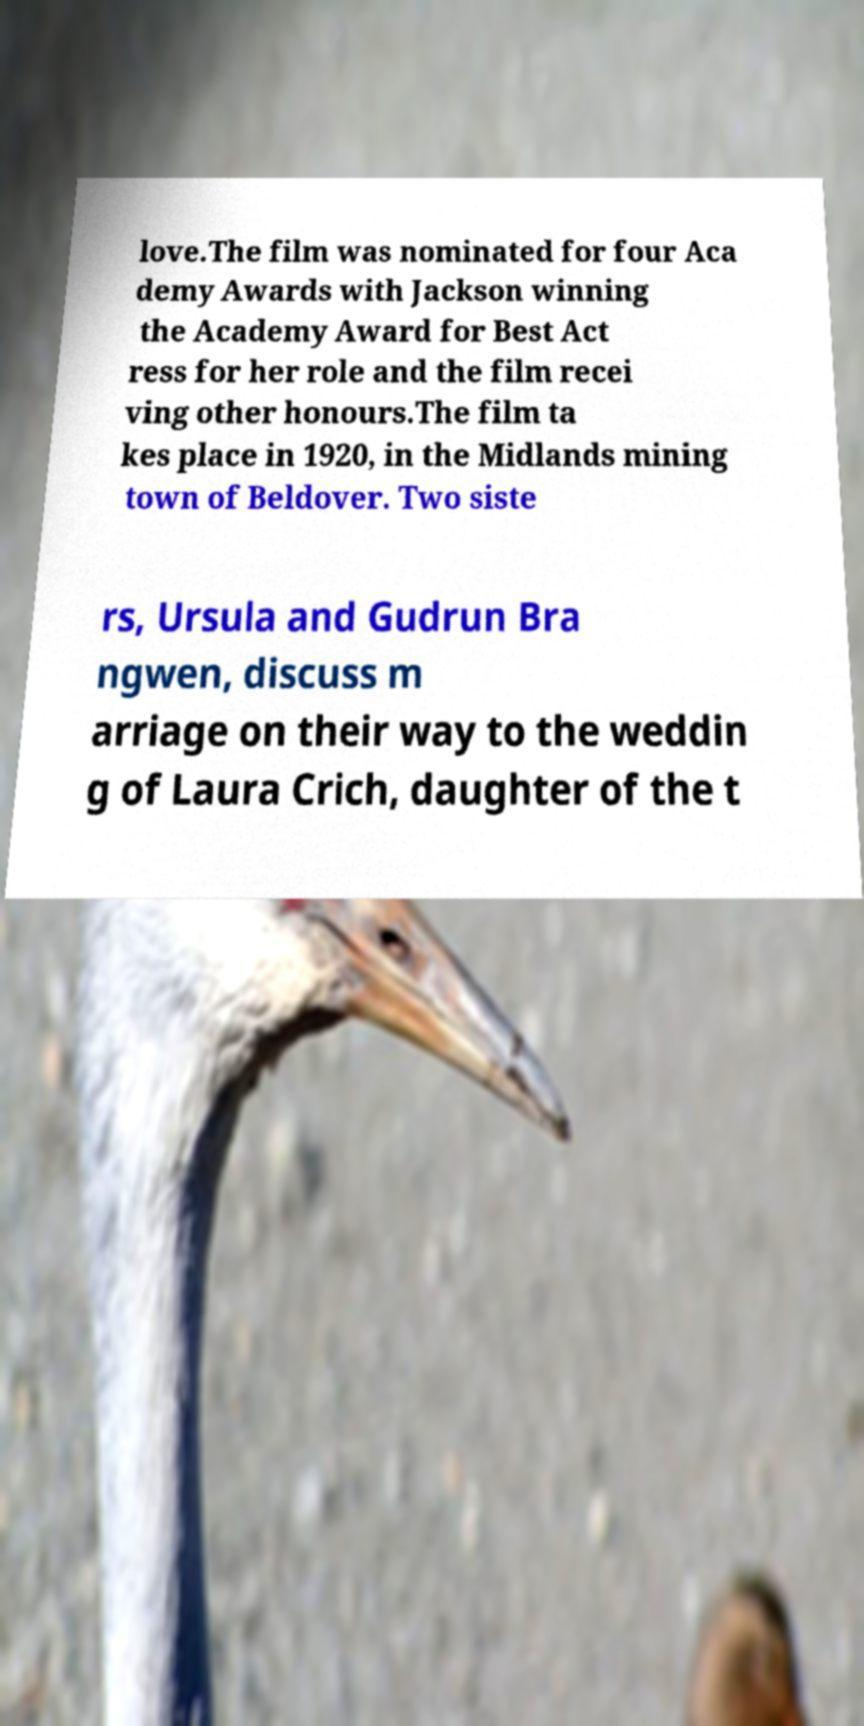I need the written content from this picture converted into text. Can you do that? love.The film was nominated for four Aca demy Awards with Jackson winning the Academy Award for Best Act ress for her role and the film recei ving other honours.The film ta kes place in 1920, in the Midlands mining town of Beldover. Two siste rs, Ursula and Gudrun Bra ngwen, discuss m arriage on their way to the weddin g of Laura Crich, daughter of the t 